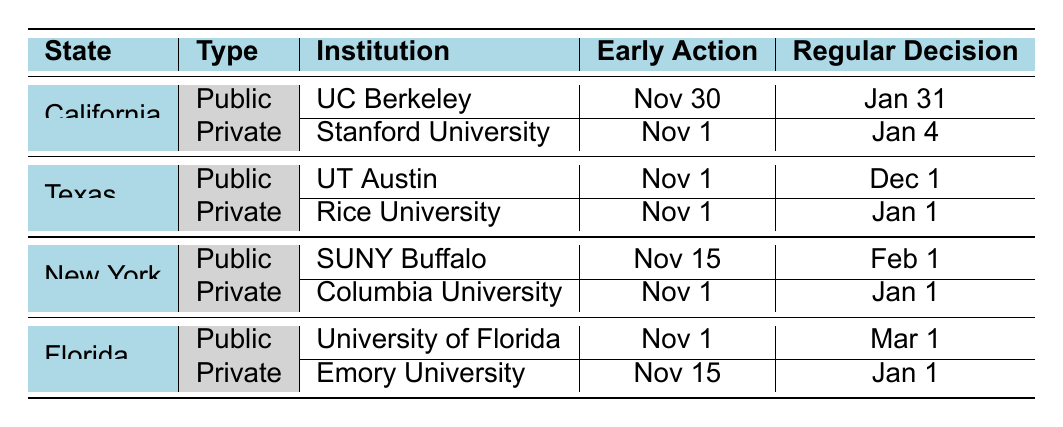What is the early action deadline for Stanford University? The table lists Stanford University under California as a Private University. For early action, the specific deadline mentioned is November 1.
Answer: November 1 Which university in Texas has a later regular decision deadline, UT Austin or Rice University? Checking the regular decision deadlines, UT Austin has a deadline of December 1, while Rice University has a deadline of January 1. Therefore, Rice University has the later deadline.
Answer: Rice University Is there a university in Florida that has an early action deadline of November 1? According to the table, the University of Florida, which is a Public University in Florida, has an early action deadline of November 1. Hence, the statement is true.
Answer: Yes What is the difference in days between the early action deadlines for Columbia University and SUNY Buffalo? Columbia University has an early action deadline of November 1, while SUNY Buffalo has an early action deadline of November 15. The difference in days is 15 - 1 = 14 days.
Answer: 14 days Which institution has the earliest regular decision deadline, Stanford University or UC Berkeley? Looking at the regular decision deadlines, Stanford University has a deadline of January 4, while UC Berkeley has a deadline of January 31. Therefore, Stanford University has the earlier deadline.
Answer: Stanford University How many universities listed have the same early action deadline of November 1? The universities with an early action deadline of November 1 are Stanford University, UT Austin, Rice University, Columbia University, and the University of Florida. Counting these gives a total of 5 universities.
Answer: 5 Does any public university have a regular decision deadline that extends beyond March? The table shows that the University of Florida (a Public University) has a regular decision deadline of March 1. This indicates that there are no public universities in the table with regular decision deadlines extending beyond March.
Answer: No What is the average early action deadline for public universities in the table? The early action deadlines for public universities are November 30 (UC Berkeley), November 1 (UT Austin), November 15 (SUNY Buffalo), and November 1 (University of Florida). To calculate the average, we first need to convert the dates to a numerical format: Nov 1 = 1, Nov 15 = 15, Nov 30 = 30. The total is 1 + 15 + 30 + 1 = 47. Since there are four deadlines, the average is 47 / 4 = 11.75, which corresponds to November 11 (rounding to the nearest date).
Answer: November 11 Which university has the longest regular decision deadline and what is that deadline? From the table, we see that the longest regular decision deadline is March 1 for the University of Florida, with other schools having earlier deadlines. This makes University of Florida the answer.
Answer: University of Florida, March 1 